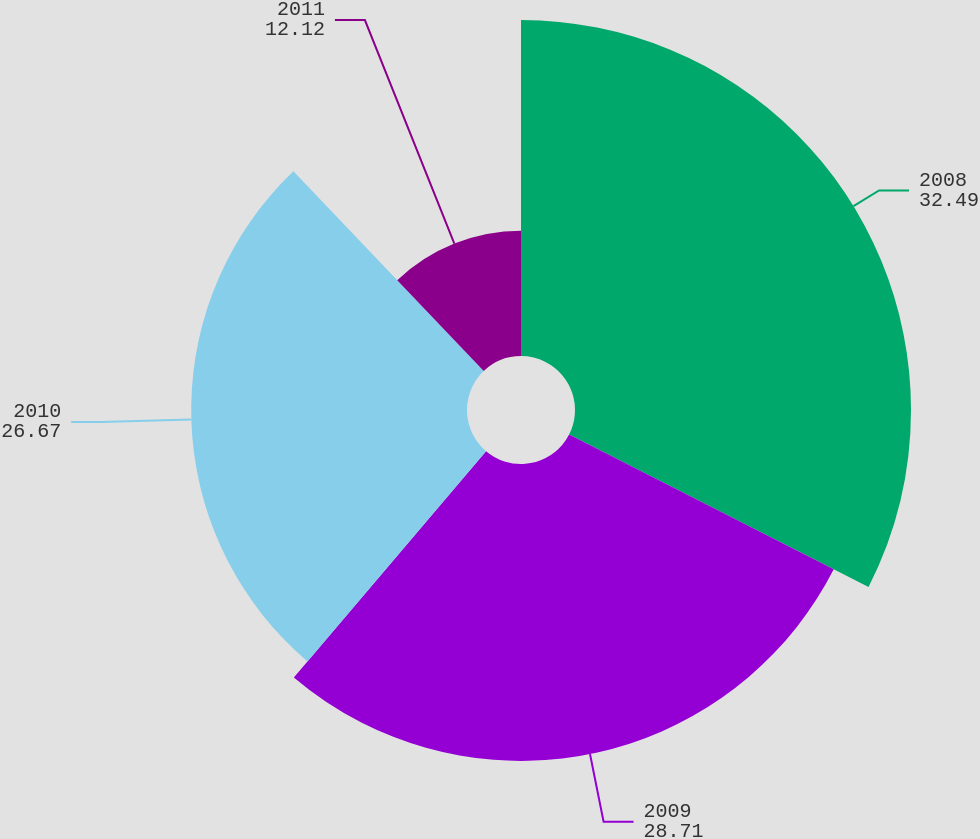Convert chart to OTSL. <chart><loc_0><loc_0><loc_500><loc_500><pie_chart><fcel>2008<fcel>2009<fcel>2010<fcel>2011<nl><fcel>32.49%<fcel>28.71%<fcel>26.67%<fcel>12.12%<nl></chart> 